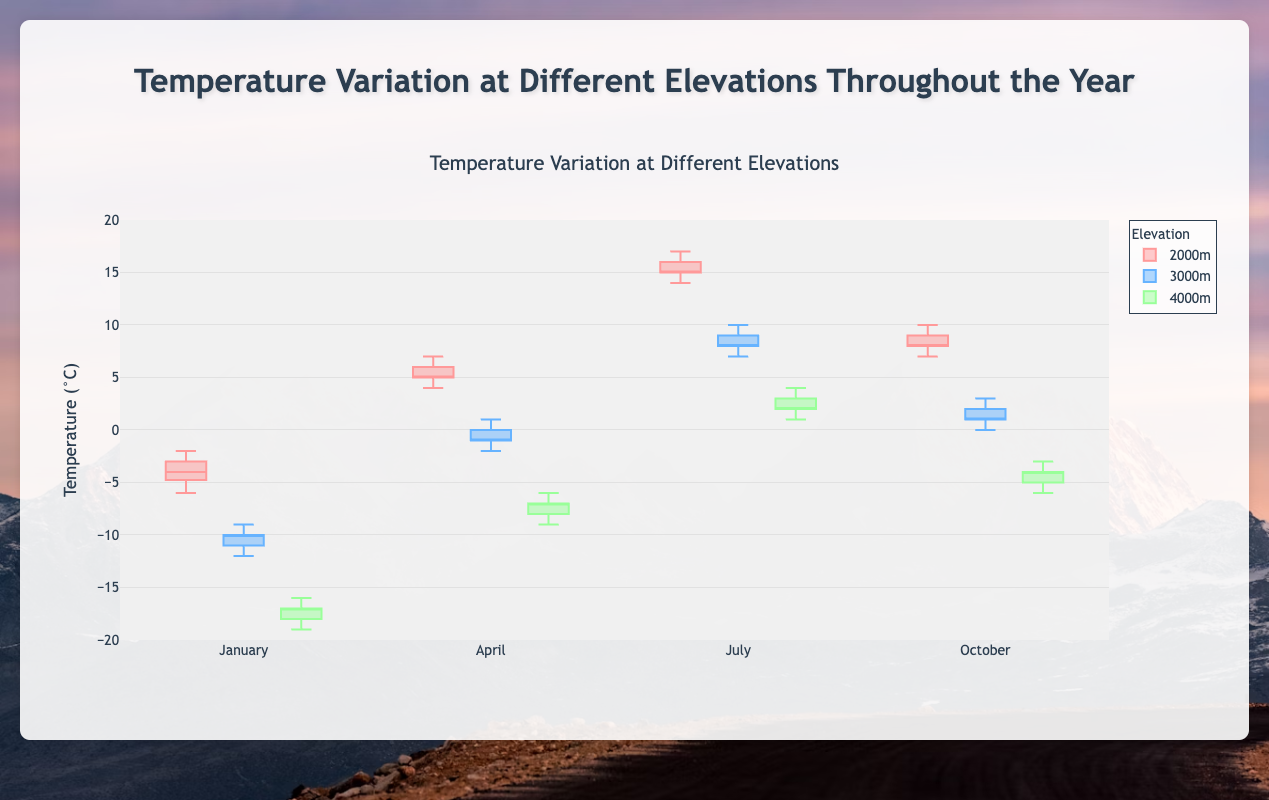What is the title of this figure? The title is usually located at the top of the figure and gives an overview of what the figure is about. In this case, it tells us that the figure is about temperature variation at different elevations throughout the year.
Answer: Temperature Variation at Different Elevations Throughout the Year What is the range of the y-axis in this plot? The y-axis range can be identified by looking at the minimum and maximum values marked along the y-axis. Here, it ranges from -20 to 20 degrees Celsius.
Answer: -20 to 20 degrees Celsius Which month shows the highest temperatures at 3000m elevation? By comparing the medians of the box plots for each month at the 3000m elevation, the month with the highest median indicates the highest temperatures. July has the highest temperatures.
Answer: July What is the median temperature at 4000m elevation in January? The median value of a box plot is represented by the line inside the box. For January at 4000m, we look for the middle line in the box for January. It is around -17 degrees Celsius.
Answer: -17°C In which month and at which elevation is the temperature variation the smallest? Temperature variation is identified by the range between the upper and lower whiskers of the box plot. The smallest range indicates the smallest variation. April at 2000m has the smallest variation.
Answer: April at 2000m Which month has the largest temperature variation at 2000m elevation? The largest variation corresponds to the widest span between the whiskers. Comparing the boxes for each month at 2000m, July shows the largest variation.
Answer: July What is the approximate interquartile range (IQR) for temperatures at 3000m elevation in October? The IQR is the range within the box itself, between the first (Q1) and third (Q3) quartiles. The box for October at 3000m spans from 0 to 2.5 degrees Celsius. Hence, IQR = Q3 - Q1.
Answer: 2.5°C Which months have below-freezing median temperatures at 4000m elevation? Median temperatures are identified by the line inside the box. For temperatures below 0°C, January, April, and October show below-freezing median temperatures.
Answer: January, April, October In which month is the temperature at 2000m elevation closest to 0°C? To find the temperature closest to 0°C, compare the boxes and whiskers around this mark. April is closest to 0°C.
Answer: April What elevation has the coldest temperatures in July? By comparing the box plots of July, the elevation with the lower medians and quartiles represents the coldest. 4000m elevation has the coldest temperatures in July.
Answer: 4000m 